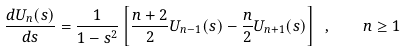Convert formula to latex. <formula><loc_0><loc_0><loc_500><loc_500>\frac { d U _ { n } ( s ) } { d s } = \frac { 1 } { 1 - s ^ { 2 } } \left [ \frac { n + 2 } { 2 } U _ { n - 1 } ( s ) - \frac { n } { 2 } U _ { n + 1 } ( s ) \right ] \ , \quad n \geq 1</formula> 